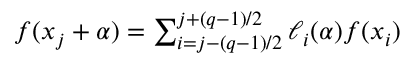<formula> <loc_0><loc_0><loc_500><loc_500>\begin{array} { r } { f ( x _ { j } + \alpha ) = \sum _ { i = j - ( q - 1 ) / 2 } ^ { j + ( q - 1 ) / 2 } \ell _ { i } ( \alpha ) f ( x _ { i } ) } \end{array}</formula> 